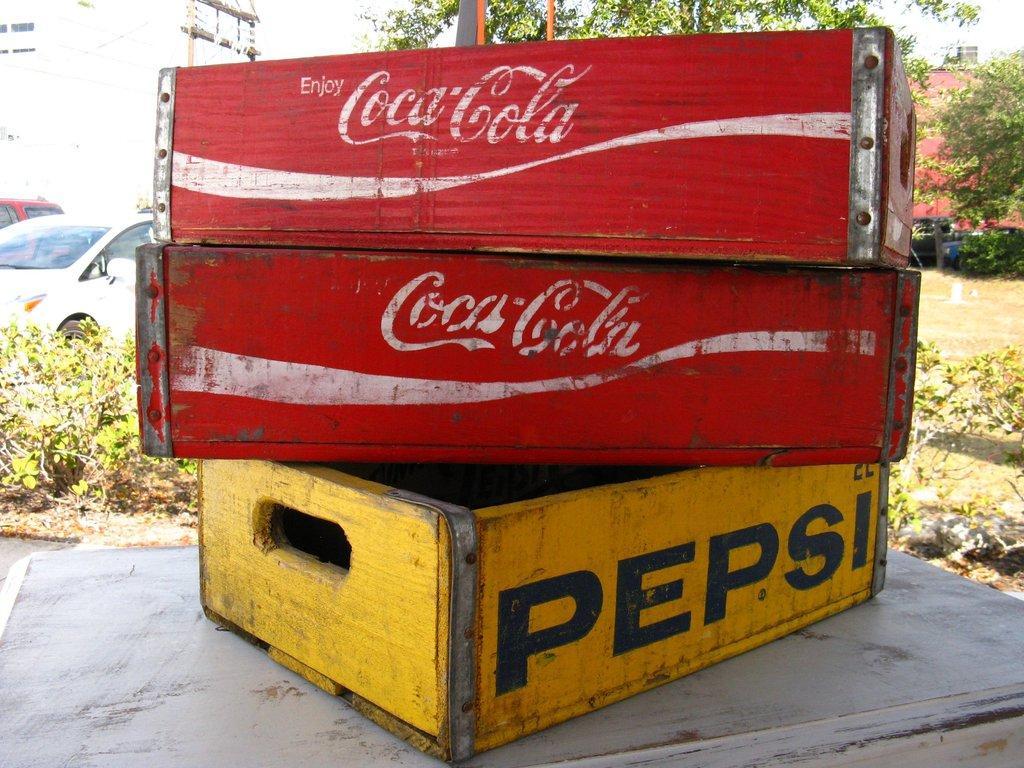Can you describe this image briefly? In this picture, we see a wooden cool drink cases in yellow and red color. These cases are placed on the white table. Behind that, we see the plants. On the left side, we see the cars in red and white color. In the background, we see a pole, electric pole and trees. We see a red color building in the background. 